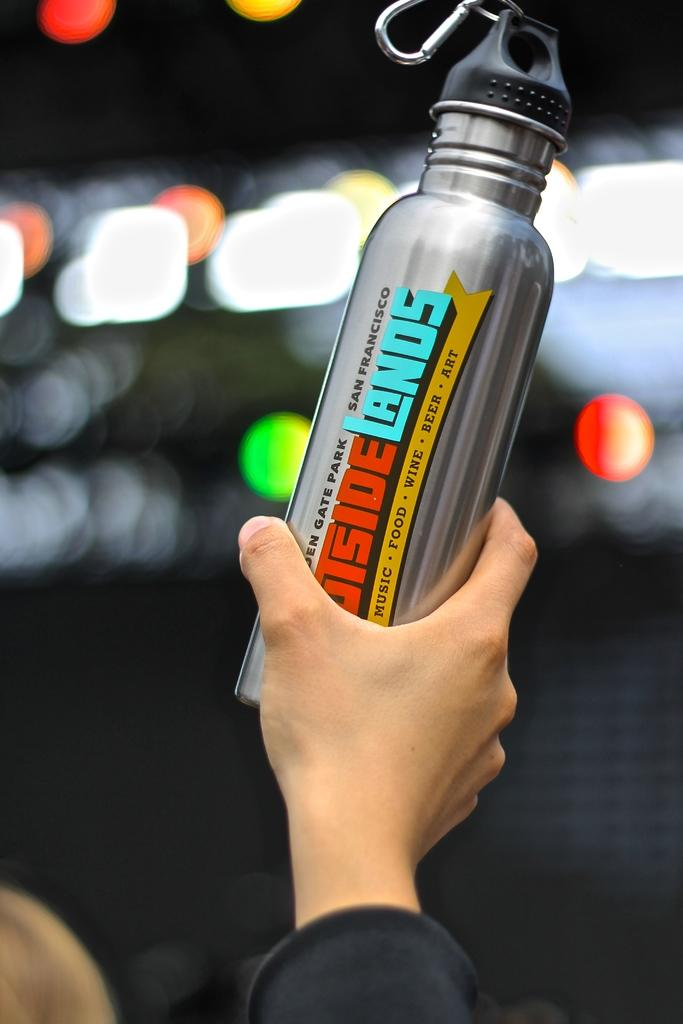What is the person holding in the image? There is a hand holding a metal bottle in the image. What can be seen on the metal bottle? The metal bottle has text on it. What can be seen in the background of the image? There are lights visible on the backside of the image. What type of skate is being used by the person in the image? There is no skate present in the image; it only shows a hand holding a metal bottle. How many umbrellas are visible in the image? There are no umbrellas present in the image. 